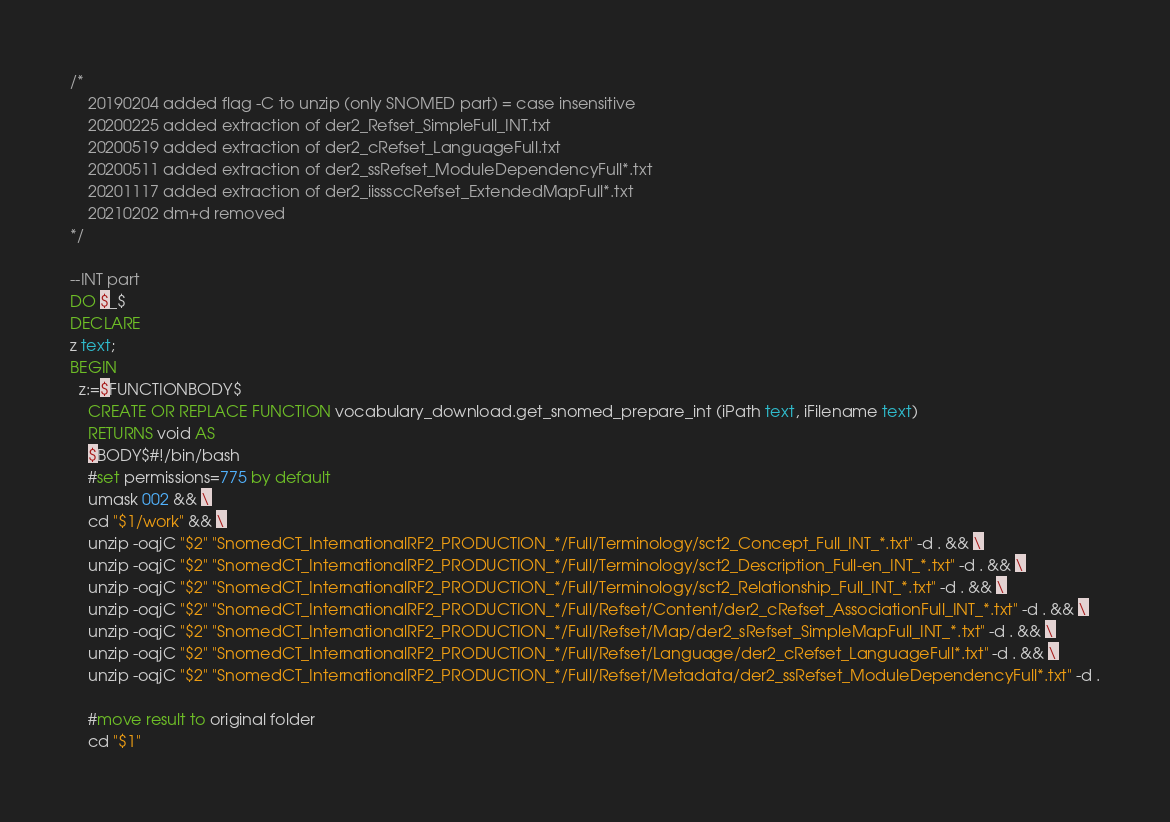<code> <loc_0><loc_0><loc_500><loc_500><_SQL_>/*
	20190204 added flag -C to unzip (only SNOMED part) = case insensitive
	20200225 added extraction of der2_Refset_SimpleFull_INT.txt
	20200519 added extraction of der2_cRefset_LanguageFull.txt
	20200511 added extraction of der2_ssRefset_ModuleDependencyFull*.txt
	20201117 added extraction of der2_iisssccRefset_ExtendedMapFull*.txt
	20210202 dm+d removed
*/

--INT part
DO $_$
DECLARE
z text;
BEGIN
  z:=$FUNCTIONBODY$
    CREATE OR REPLACE FUNCTION vocabulary_download.get_snomed_prepare_int (iPath text, iFilename text)
    RETURNS void AS
    $BODY$#!/bin/bash
    #set permissions=775 by default
    umask 002 && \
    cd "$1/work" && \
    unzip -oqjC "$2" "SnomedCT_InternationalRF2_PRODUCTION_*/Full/Terminology/sct2_Concept_Full_INT_*.txt" -d . && \
    unzip -oqjC "$2" "SnomedCT_InternationalRF2_PRODUCTION_*/Full/Terminology/sct2_Description_Full-en_INT_*.txt" -d . && \
    unzip -oqjC "$2" "SnomedCT_InternationalRF2_PRODUCTION_*/Full/Terminology/sct2_Relationship_Full_INT_*.txt" -d . && \
    unzip -oqjC "$2" "SnomedCT_InternationalRF2_PRODUCTION_*/Full/Refset/Content/der2_cRefset_AssociationFull_INT_*.txt" -d . && \
    unzip -oqjC "$2" "SnomedCT_InternationalRF2_PRODUCTION_*/Full/Refset/Map/der2_sRefset_SimpleMapFull_INT_*.txt" -d . && \
    unzip -oqjC "$2" "SnomedCT_InternationalRF2_PRODUCTION_*/Full/Refset/Language/der2_cRefset_LanguageFull*.txt" -d . && \
    unzip -oqjC "$2" "SnomedCT_InternationalRF2_PRODUCTION_*/Full/Refset/Metadata/der2_ssRefset_ModuleDependencyFull*.txt" -d .
        
    #move result to original folder
    cd "$1"</code> 